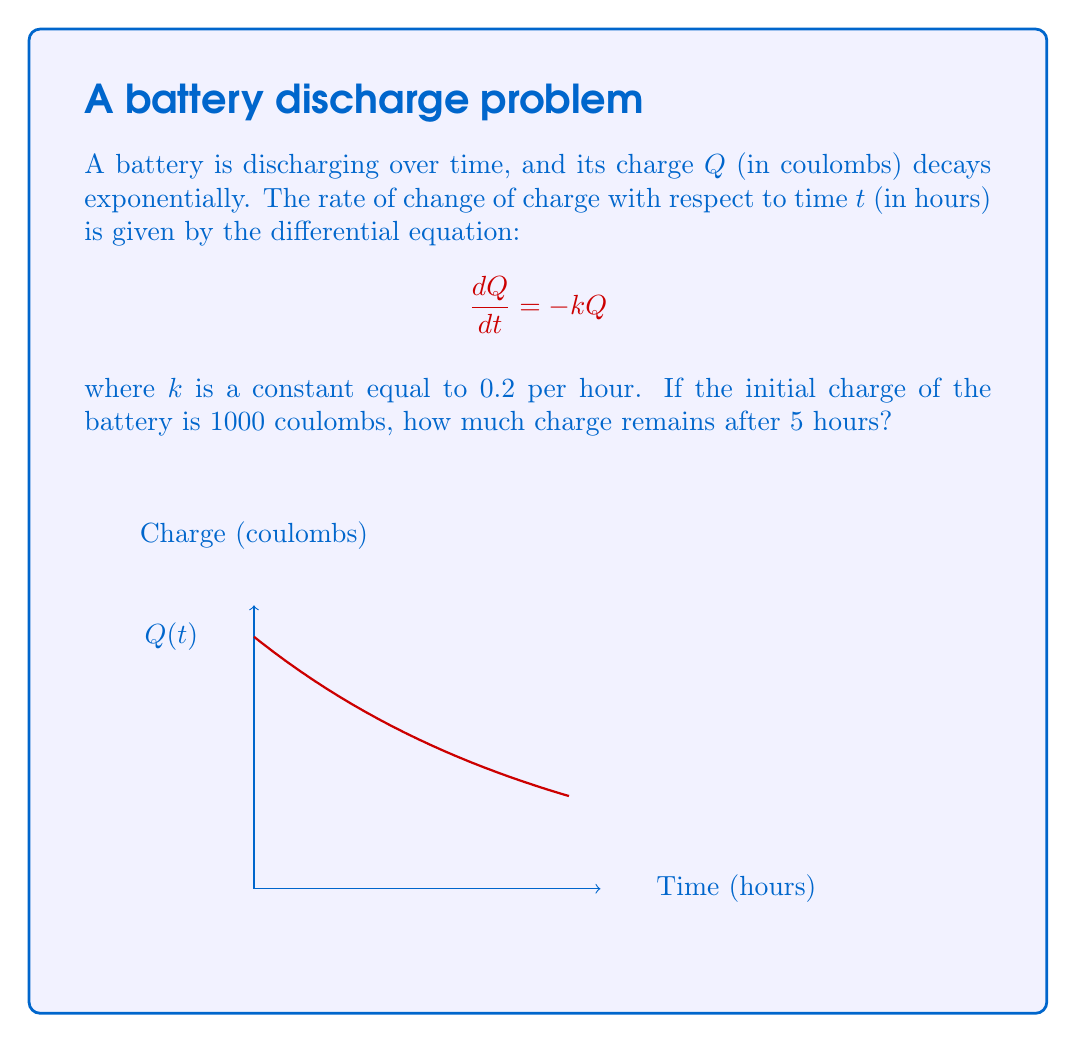Can you solve this math problem? Let's solve this step-by-step:

1) The differential equation given is:
   $$\frac{dQ}{dt} = -kQ$$

2) This is a separable equation. We can rewrite it as:
   $$\frac{dQ}{Q} = -k dt$$

3) Integrating both sides:
   $$\int \frac{dQ}{Q} = -k \int dt$$

4) This gives us:
   $$\ln|Q| = -kt + C$$
   where $C$ is a constant of integration.

5) Solving for $Q$:
   $$Q = e^{-kt + C} = e^C \cdot e^{-kt}$$

6) Let $Q_0$ be the initial charge. At $t=0$, $Q = Q_0 = 1000$. So:
   $$1000 = e^C \cdot e^0 = e^C$$
   $$e^C = 1000$$

7) Therefore, our solution is:
   $$Q = 1000 \cdot e^{-kt}$$

8) We're given that $k = 0.2$ and we want to find $Q$ when $t = 5$:
   $$Q = 1000 \cdot e^{-0.2 \cdot 5}$$

9) Calculating this:
   $$Q = 1000 \cdot e^{-1} \approx 367.88$$

Therefore, after 5 hours, approximately 367.88 coulombs of charge remain in the battery.
Answer: 367.88 coulombs 